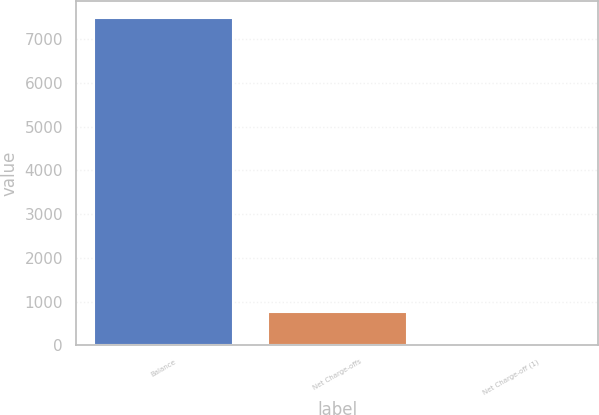Convert chart to OTSL. <chart><loc_0><loc_0><loc_500><loc_500><bar_chart><fcel>Balance<fcel>Net Charge-offs<fcel>Net Charge-off (1)<nl><fcel>7497<fcel>750.71<fcel>1.12<nl></chart> 